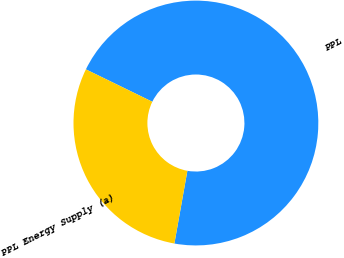Convert chart to OTSL. <chart><loc_0><loc_0><loc_500><loc_500><pie_chart><fcel>PPL<fcel>PPL Energy Supply (a)<nl><fcel>70.59%<fcel>29.41%<nl></chart> 